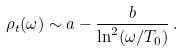<formula> <loc_0><loc_0><loc_500><loc_500>\rho _ { t } ( \omega ) \sim a - \frac { b } { \ln ^ { 2 } ( \omega / T _ { 0 } ) } \, .</formula> 